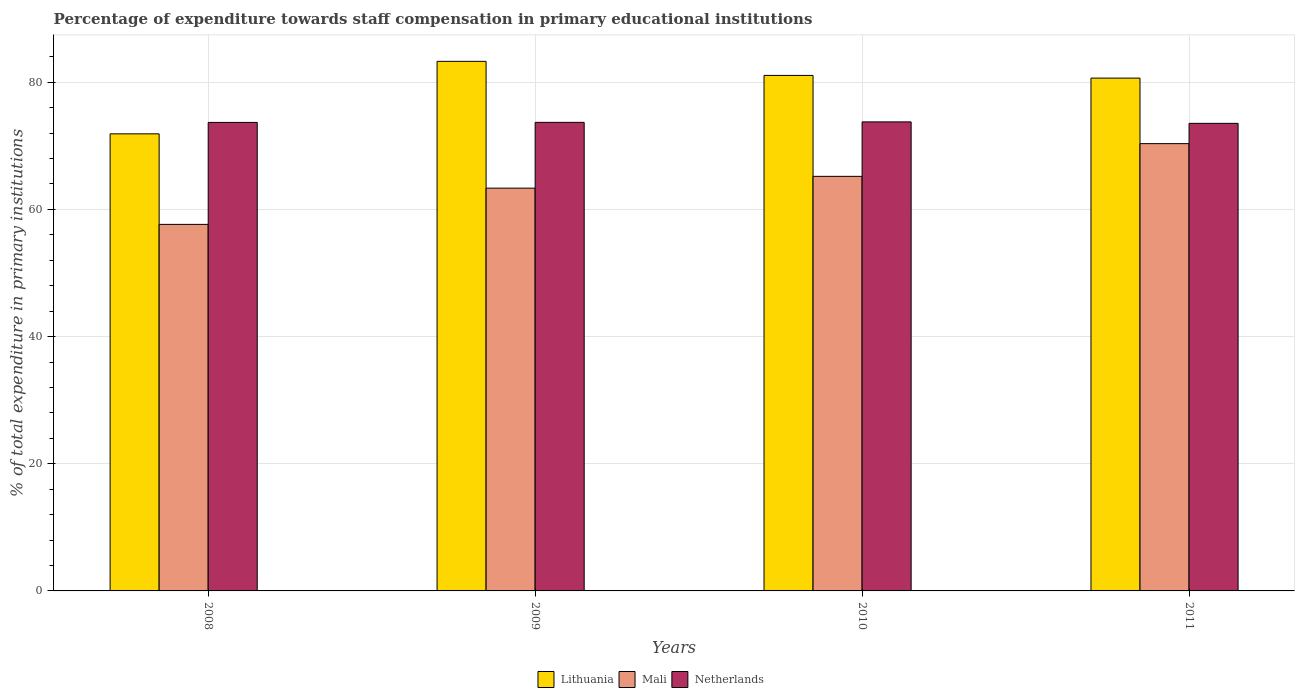How many different coloured bars are there?
Offer a very short reply. 3. How many groups of bars are there?
Ensure brevity in your answer.  4. Are the number of bars on each tick of the X-axis equal?
Give a very brief answer. Yes. How many bars are there on the 3rd tick from the left?
Your response must be concise. 3. What is the label of the 4th group of bars from the left?
Your response must be concise. 2011. In how many cases, is the number of bars for a given year not equal to the number of legend labels?
Your answer should be compact. 0. What is the percentage of expenditure towards staff compensation in Lithuania in 2010?
Your answer should be compact. 81.08. Across all years, what is the maximum percentage of expenditure towards staff compensation in Netherlands?
Give a very brief answer. 73.77. Across all years, what is the minimum percentage of expenditure towards staff compensation in Mali?
Give a very brief answer. 57.65. In which year was the percentage of expenditure towards staff compensation in Lithuania maximum?
Provide a succinct answer. 2009. In which year was the percentage of expenditure towards staff compensation in Lithuania minimum?
Offer a very short reply. 2008. What is the total percentage of expenditure towards staff compensation in Mali in the graph?
Offer a terse response. 256.54. What is the difference between the percentage of expenditure towards staff compensation in Lithuania in 2008 and that in 2010?
Make the answer very short. -9.19. What is the difference between the percentage of expenditure towards staff compensation in Lithuania in 2008 and the percentage of expenditure towards staff compensation in Mali in 2010?
Provide a short and direct response. 6.69. What is the average percentage of expenditure towards staff compensation in Lithuania per year?
Offer a terse response. 79.23. In the year 2010, what is the difference between the percentage of expenditure towards staff compensation in Netherlands and percentage of expenditure towards staff compensation in Mali?
Your response must be concise. 8.57. What is the ratio of the percentage of expenditure towards staff compensation in Lithuania in 2009 to that in 2011?
Your answer should be compact. 1.03. Is the percentage of expenditure towards staff compensation in Lithuania in 2009 less than that in 2011?
Your response must be concise. No. Is the difference between the percentage of expenditure towards staff compensation in Netherlands in 2008 and 2010 greater than the difference between the percentage of expenditure towards staff compensation in Mali in 2008 and 2010?
Ensure brevity in your answer.  Yes. What is the difference between the highest and the second highest percentage of expenditure towards staff compensation in Netherlands?
Provide a short and direct response. 0.07. What is the difference between the highest and the lowest percentage of expenditure towards staff compensation in Lithuania?
Make the answer very short. 11.4. Is the sum of the percentage of expenditure towards staff compensation in Lithuania in 2010 and 2011 greater than the maximum percentage of expenditure towards staff compensation in Netherlands across all years?
Ensure brevity in your answer.  Yes. What does the 2nd bar from the left in 2008 represents?
Provide a succinct answer. Mali. What does the 3rd bar from the right in 2011 represents?
Offer a terse response. Lithuania. How many years are there in the graph?
Give a very brief answer. 4. What is the difference between two consecutive major ticks on the Y-axis?
Give a very brief answer. 20. Are the values on the major ticks of Y-axis written in scientific E-notation?
Offer a terse response. No. Does the graph contain any zero values?
Your answer should be very brief. No. How many legend labels are there?
Offer a terse response. 3. What is the title of the graph?
Provide a short and direct response. Percentage of expenditure towards staff compensation in primary educational institutions. Does "St. Kitts and Nevis" appear as one of the legend labels in the graph?
Offer a terse response. No. What is the label or title of the Y-axis?
Offer a very short reply. % of total expenditure in primary institutions. What is the % of total expenditure in primary institutions of Lithuania in 2008?
Give a very brief answer. 71.89. What is the % of total expenditure in primary institutions in Mali in 2008?
Provide a succinct answer. 57.65. What is the % of total expenditure in primary institutions in Netherlands in 2008?
Offer a very short reply. 73.68. What is the % of total expenditure in primary institutions of Lithuania in 2009?
Offer a very short reply. 83.29. What is the % of total expenditure in primary institutions of Mali in 2009?
Your answer should be compact. 63.35. What is the % of total expenditure in primary institutions in Netherlands in 2009?
Your response must be concise. 73.69. What is the % of total expenditure in primary institutions in Lithuania in 2010?
Your answer should be compact. 81.08. What is the % of total expenditure in primary institutions of Mali in 2010?
Ensure brevity in your answer.  65.2. What is the % of total expenditure in primary institutions in Netherlands in 2010?
Your answer should be compact. 73.77. What is the % of total expenditure in primary institutions in Lithuania in 2011?
Your answer should be compact. 80.66. What is the % of total expenditure in primary institutions in Mali in 2011?
Offer a terse response. 70.35. What is the % of total expenditure in primary institutions in Netherlands in 2011?
Offer a terse response. 73.54. Across all years, what is the maximum % of total expenditure in primary institutions of Lithuania?
Keep it short and to the point. 83.29. Across all years, what is the maximum % of total expenditure in primary institutions of Mali?
Your answer should be very brief. 70.35. Across all years, what is the maximum % of total expenditure in primary institutions in Netherlands?
Give a very brief answer. 73.77. Across all years, what is the minimum % of total expenditure in primary institutions of Lithuania?
Give a very brief answer. 71.89. Across all years, what is the minimum % of total expenditure in primary institutions of Mali?
Provide a succinct answer. 57.65. Across all years, what is the minimum % of total expenditure in primary institutions of Netherlands?
Provide a succinct answer. 73.54. What is the total % of total expenditure in primary institutions of Lithuania in the graph?
Provide a short and direct response. 316.91. What is the total % of total expenditure in primary institutions of Mali in the graph?
Your answer should be very brief. 256.54. What is the total % of total expenditure in primary institutions in Netherlands in the graph?
Offer a very short reply. 294.68. What is the difference between the % of total expenditure in primary institutions of Lithuania in 2008 and that in 2009?
Ensure brevity in your answer.  -11.4. What is the difference between the % of total expenditure in primary institutions of Mali in 2008 and that in 2009?
Your answer should be very brief. -5.7. What is the difference between the % of total expenditure in primary institutions of Netherlands in 2008 and that in 2009?
Give a very brief answer. -0.01. What is the difference between the % of total expenditure in primary institutions of Lithuania in 2008 and that in 2010?
Give a very brief answer. -9.19. What is the difference between the % of total expenditure in primary institutions of Mali in 2008 and that in 2010?
Keep it short and to the point. -7.55. What is the difference between the % of total expenditure in primary institutions in Netherlands in 2008 and that in 2010?
Give a very brief answer. -0.08. What is the difference between the % of total expenditure in primary institutions of Lithuania in 2008 and that in 2011?
Your answer should be very brief. -8.77. What is the difference between the % of total expenditure in primary institutions in Mali in 2008 and that in 2011?
Provide a short and direct response. -12.7. What is the difference between the % of total expenditure in primary institutions of Netherlands in 2008 and that in 2011?
Make the answer very short. 0.15. What is the difference between the % of total expenditure in primary institutions of Lithuania in 2009 and that in 2010?
Make the answer very short. 2.21. What is the difference between the % of total expenditure in primary institutions of Mali in 2009 and that in 2010?
Give a very brief answer. -1.85. What is the difference between the % of total expenditure in primary institutions in Netherlands in 2009 and that in 2010?
Ensure brevity in your answer.  -0.07. What is the difference between the % of total expenditure in primary institutions in Lithuania in 2009 and that in 2011?
Your response must be concise. 2.63. What is the difference between the % of total expenditure in primary institutions in Mali in 2009 and that in 2011?
Your response must be concise. -7. What is the difference between the % of total expenditure in primary institutions of Netherlands in 2009 and that in 2011?
Your answer should be compact. 0.16. What is the difference between the % of total expenditure in primary institutions in Lithuania in 2010 and that in 2011?
Provide a short and direct response. 0.42. What is the difference between the % of total expenditure in primary institutions of Mali in 2010 and that in 2011?
Provide a short and direct response. -5.15. What is the difference between the % of total expenditure in primary institutions in Netherlands in 2010 and that in 2011?
Offer a terse response. 0.23. What is the difference between the % of total expenditure in primary institutions of Lithuania in 2008 and the % of total expenditure in primary institutions of Mali in 2009?
Keep it short and to the point. 8.54. What is the difference between the % of total expenditure in primary institutions in Lithuania in 2008 and the % of total expenditure in primary institutions in Netherlands in 2009?
Your answer should be compact. -1.8. What is the difference between the % of total expenditure in primary institutions of Mali in 2008 and the % of total expenditure in primary institutions of Netherlands in 2009?
Offer a terse response. -16.04. What is the difference between the % of total expenditure in primary institutions of Lithuania in 2008 and the % of total expenditure in primary institutions of Mali in 2010?
Provide a short and direct response. 6.69. What is the difference between the % of total expenditure in primary institutions of Lithuania in 2008 and the % of total expenditure in primary institutions of Netherlands in 2010?
Ensure brevity in your answer.  -1.88. What is the difference between the % of total expenditure in primary institutions in Mali in 2008 and the % of total expenditure in primary institutions in Netherlands in 2010?
Your answer should be compact. -16.12. What is the difference between the % of total expenditure in primary institutions of Lithuania in 2008 and the % of total expenditure in primary institutions of Mali in 2011?
Your answer should be compact. 1.54. What is the difference between the % of total expenditure in primary institutions in Lithuania in 2008 and the % of total expenditure in primary institutions in Netherlands in 2011?
Offer a terse response. -1.65. What is the difference between the % of total expenditure in primary institutions of Mali in 2008 and the % of total expenditure in primary institutions of Netherlands in 2011?
Ensure brevity in your answer.  -15.89. What is the difference between the % of total expenditure in primary institutions in Lithuania in 2009 and the % of total expenditure in primary institutions in Mali in 2010?
Make the answer very short. 18.09. What is the difference between the % of total expenditure in primary institutions of Lithuania in 2009 and the % of total expenditure in primary institutions of Netherlands in 2010?
Give a very brief answer. 9.52. What is the difference between the % of total expenditure in primary institutions of Mali in 2009 and the % of total expenditure in primary institutions of Netherlands in 2010?
Keep it short and to the point. -10.42. What is the difference between the % of total expenditure in primary institutions of Lithuania in 2009 and the % of total expenditure in primary institutions of Mali in 2011?
Make the answer very short. 12.94. What is the difference between the % of total expenditure in primary institutions in Lithuania in 2009 and the % of total expenditure in primary institutions in Netherlands in 2011?
Offer a very short reply. 9.75. What is the difference between the % of total expenditure in primary institutions of Mali in 2009 and the % of total expenditure in primary institutions of Netherlands in 2011?
Offer a terse response. -10.19. What is the difference between the % of total expenditure in primary institutions of Lithuania in 2010 and the % of total expenditure in primary institutions of Mali in 2011?
Keep it short and to the point. 10.73. What is the difference between the % of total expenditure in primary institutions in Lithuania in 2010 and the % of total expenditure in primary institutions in Netherlands in 2011?
Provide a succinct answer. 7.54. What is the difference between the % of total expenditure in primary institutions in Mali in 2010 and the % of total expenditure in primary institutions in Netherlands in 2011?
Give a very brief answer. -8.34. What is the average % of total expenditure in primary institutions of Lithuania per year?
Offer a terse response. 79.23. What is the average % of total expenditure in primary institutions in Mali per year?
Offer a terse response. 64.14. What is the average % of total expenditure in primary institutions in Netherlands per year?
Provide a succinct answer. 73.67. In the year 2008, what is the difference between the % of total expenditure in primary institutions in Lithuania and % of total expenditure in primary institutions in Mali?
Offer a terse response. 14.24. In the year 2008, what is the difference between the % of total expenditure in primary institutions of Lithuania and % of total expenditure in primary institutions of Netherlands?
Offer a very short reply. -1.8. In the year 2008, what is the difference between the % of total expenditure in primary institutions in Mali and % of total expenditure in primary institutions in Netherlands?
Provide a succinct answer. -16.04. In the year 2009, what is the difference between the % of total expenditure in primary institutions of Lithuania and % of total expenditure in primary institutions of Mali?
Give a very brief answer. 19.94. In the year 2009, what is the difference between the % of total expenditure in primary institutions in Lithuania and % of total expenditure in primary institutions in Netherlands?
Offer a very short reply. 9.6. In the year 2009, what is the difference between the % of total expenditure in primary institutions in Mali and % of total expenditure in primary institutions in Netherlands?
Make the answer very short. -10.35. In the year 2010, what is the difference between the % of total expenditure in primary institutions in Lithuania and % of total expenditure in primary institutions in Mali?
Offer a terse response. 15.88. In the year 2010, what is the difference between the % of total expenditure in primary institutions in Lithuania and % of total expenditure in primary institutions in Netherlands?
Ensure brevity in your answer.  7.31. In the year 2010, what is the difference between the % of total expenditure in primary institutions in Mali and % of total expenditure in primary institutions in Netherlands?
Provide a short and direct response. -8.57. In the year 2011, what is the difference between the % of total expenditure in primary institutions in Lithuania and % of total expenditure in primary institutions in Mali?
Keep it short and to the point. 10.31. In the year 2011, what is the difference between the % of total expenditure in primary institutions in Lithuania and % of total expenditure in primary institutions in Netherlands?
Your response must be concise. 7.12. In the year 2011, what is the difference between the % of total expenditure in primary institutions of Mali and % of total expenditure in primary institutions of Netherlands?
Your response must be concise. -3.19. What is the ratio of the % of total expenditure in primary institutions of Lithuania in 2008 to that in 2009?
Your answer should be very brief. 0.86. What is the ratio of the % of total expenditure in primary institutions of Mali in 2008 to that in 2009?
Keep it short and to the point. 0.91. What is the ratio of the % of total expenditure in primary institutions of Lithuania in 2008 to that in 2010?
Offer a terse response. 0.89. What is the ratio of the % of total expenditure in primary institutions in Mali in 2008 to that in 2010?
Provide a succinct answer. 0.88. What is the ratio of the % of total expenditure in primary institutions in Lithuania in 2008 to that in 2011?
Make the answer very short. 0.89. What is the ratio of the % of total expenditure in primary institutions in Mali in 2008 to that in 2011?
Your response must be concise. 0.82. What is the ratio of the % of total expenditure in primary institutions in Netherlands in 2008 to that in 2011?
Keep it short and to the point. 1. What is the ratio of the % of total expenditure in primary institutions in Lithuania in 2009 to that in 2010?
Keep it short and to the point. 1.03. What is the ratio of the % of total expenditure in primary institutions in Mali in 2009 to that in 2010?
Your response must be concise. 0.97. What is the ratio of the % of total expenditure in primary institutions of Netherlands in 2009 to that in 2010?
Offer a terse response. 1. What is the ratio of the % of total expenditure in primary institutions of Lithuania in 2009 to that in 2011?
Make the answer very short. 1.03. What is the ratio of the % of total expenditure in primary institutions of Mali in 2009 to that in 2011?
Provide a succinct answer. 0.9. What is the ratio of the % of total expenditure in primary institutions of Mali in 2010 to that in 2011?
Provide a short and direct response. 0.93. What is the difference between the highest and the second highest % of total expenditure in primary institutions in Lithuania?
Give a very brief answer. 2.21. What is the difference between the highest and the second highest % of total expenditure in primary institutions of Mali?
Your response must be concise. 5.15. What is the difference between the highest and the second highest % of total expenditure in primary institutions of Netherlands?
Ensure brevity in your answer.  0.07. What is the difference between the highest and the lowest % of total expenditure in primary institutions in Lithuania?
Offer a very short reply. 11.4. What is the difference between the highest and the lowest % of total expenditure in primary institutions in Mali?
Your response must be concise. 12.7. What is the difference between the highest and the lowest % of total expenditure in primary institutions in Netherlands?
Offer a very short reply. 0.23. 